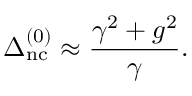Convert formula to latex. <formula><loc_0><loc_0><loc_500><loc_500>\Delta _ { n c } ^ { ( 0 ) } \approx \frac { \gamma ^ { 2 } + g ^ { 2 } } { \gamma } .</formula> 